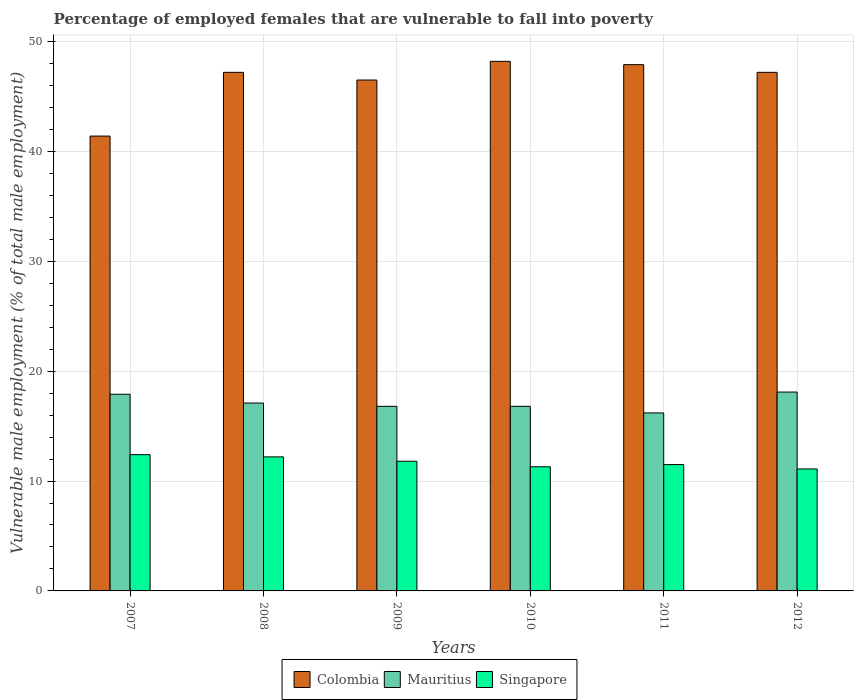Are the number of bars on each tick of the X-axis equal?
Offer a very short reply. Yes. How many bars are there on the 3rd tick from the left?
Provide a succinct answer. 3. How many bars are there on the 3rd tick from the right?
Ensure brevity in your answer.  3. What is the label of the 2nd group of bars from the left?
Your answer should be compact. 2008. In how many cases, is the number of bars for a given year not equal to the number of legend labels?
Offer a very short reply. 0. What is the percentage of employed females who are vulnerable to fall into poverty in Colombia in 2008?
Provide a short and direct response. 47.2. Across all years, what is the maximum percentage of employed females who are vulnerable to fall into poverty in Colombia?
Offer a very short reply. 48.2. Across all years, what is the minimum percentage of employed females who are vulnerable to fall into poverty in Mauritius?
Make the answer very short. 16.2. In which year was the percentage of employed females who are vulnerable to fall into poverty in Colombia minimum?
Keep it short and to the point. 2007. What is the total percentage of employed females who are vulnerable to fall into poverty in Mauritius in the graph?
Your answer should be very brief. 102.9. What is the difference between the percentage of employed females who are vulnerable to fall into poverty in Mauritius in 2007 and that in 2012?
Ensure brevity in your answer.  -0.2. What is the difference between the percentage of employed females who are vulnerable to fall into poverty in Colombia in 2007 and the percentage of employed females who are vulnerable to fall into poverty in Mauritius in 2009?
Ensure brevity in your answer.  24.6. What is the average percentage of employed females who are vulnerable to fall into poverty in Colombia per year?
Offer a very short reply. 46.4. In the year 2010, what is the difference between the percentage of employed females who are vulnerable to fall into poverty in Singapore and percentage of employed females who are vulnerable to fall into poverty in Colombia?
Provide a succinct answer. -36.9. In how many years, is the percentage of employed females who are vulnerable to fall into poverty in Mauritius greater than 16 %?
Ensure brevity in your answer.  6. What is the ratio of the percentage of employed females who are vulnerable to fall into poverty in Mauritius in 2007 to that in 2010?
Provide a succinct answer. 1.07. Is the percentage of employed females who are vulnerable to fall into poverty in Mauritius in 2007 less than that in 2011?
Ensure brevity in your answer.  No. What is the difference between the highest and the second highest percentage of employed females who are vulnerable to fall into poverty in Colombia?
Your answer should be compact. 0.3. What is the difference between the highest and the lowest percentage of employed females who are vulnerable to fall into poverty in Colombia?
Provide a succinct answer. 6.8. In how many years, is the percentage of employed females who are vulnerable to fall into poverty in Mauritius greater than the average percentage of employed females who are vulnerable to fall into poverty in Mauritius taken over all years?
Provide a short and direct response. 2. Is the sum of the percentage of employed females who are vulnerable to fall into poverty in Colombia in 2010 and 2012 greater than the maximum percentage of employed females who are vulnerable to fall into poverty in Singapore across all years?
Your answer should be very brief. Yes. What does the 1st bar from the left in 2010 represents?
Provide a succinct answer. Colombia. What does the 2nd bar from the right in 2012 represents?
Give a very brief answer. Mauritius. Is it the case that in every year, the sum of the percentage of employed females who are vulnerable to fall into poverty in Singapore and percentage of employed females who are vulnerable to fall into poverty in Mauritius is greater than the percentage of employed females who are vulnerable to fall into poverty in Colombia?
Provide a succinct answer. No. How many bars are there?
Give a very brief answer. 18. Are all the bars in the graph horizontal?
Give a very brief answer. No. How many years are there in the graph?
Your answer should be very brief. 6. What is the difference between two consecutive major ticks on the Y-axis?
Keep it short and to the point. 10. Does the graph contain any zero values?
Give a very brief answer. No. Does the graph contain grids?
Offer a very short reply. Yes. Where does the legend appear in the graph?
Offer a very short reply. Bottom center. What is the title of the graph?
Offer a terse response. Percentage of employed females that are vulnerable to fall into poverty. Does "St. Kitts and Nevis" appear as one of the legend labels in the graph?
Make the answer very short. No. What is the label or title of the Y-axis?
Offer a very short reply. Vulnerable male employment (% of total male employment). What is the Vulnerable male employment (% of total male employment) in Colombia in 2007?
Offer a very short reply. 41.4. What is the Vulnerable male employment (% of total male employment) of Mauritius in 2007?
Offer a very short reply. 17.9. What is the Vulnerable male employment (% of total male employment) in Singapore in 2007?
Ensure brevity in your answer.  12.4. What is the Vulnerable male employment (% of total male employment) of Colombia in 2008?
Make the answer very short. 47.2. What is the Vulnerable male employment (% of total male employment) in Mauritius in 2008?
Provide a succinct answer. 17.1. What is the Vulnerable male employment (% of total male employment) in Singapore in 2008?
Give a very brief answer. 12.2. What is the Vulnerable male employment (% of total male employment) in Colombia in 2009?
Provide a succinct answer. 46.5. What is the Vulnerable male employment (% of total male employment) in Mauritius in 2009?
Your answer should be very brief. 16.8. What is the Vulnerable male employment (% of total male employment) in Singapore in 2009?
Give a very brief answer. 11.8. What is the Vulnerable male employment (% of total male employment) of Colombia in 2010?
Provide a succinct answer. 48.2. What is the Vulnerable male employment (% of total male employment) of Mauritius in 2010?
Your response must be concise. 16.8. What is the Vulnerable male employment (% of total male employment) of Singapore in 2010?
Your answer should be very brief. 11.3. What is the Vulnerable male employment (% of total male employment) of Colombia in 2011?
Give a very brief answer. 47.9. What is the Vulnerable male employment (% of total male employment) in Mauritius in 2011?
Keep it short and to the point. 16.2. What is the Vulnerable male employment (% of total male employment) in Colombia in 2012?
Keep it short and to the point. 47.2. What is the Vulnerable male employment (% of total male employment) of Mauritius in 2012?
Your response must be concise. 18.1. What is the Vulnerable male employment (% of total male employment) of Singapore in 2012?
Provide a short and direct response. 11.1. Across all years, what is the maximum Vulnerable male employment (% of total male employment) in Colombia?
Provide a short and direct response. 48.2. Across all years, what is the maximum Vulnerable male employment (% of total male employment) in Mauritius?
Your answer should be very brief. 18.1. Across all years, what is the maximum Vulnerable male employment (% of total male employment) of Singapore?
Provide a succinct answer. 12.4. Across all years, what is the minimum Vulnerable male employment (% of total male employment) of Colombia?
Make the answer very short. 41.4. Across all years, what is the minimum Vulnerable male employment (% of total male employment) of Mauritius?
Make the answer very short. 16.2. Across all years, what is the minimum Vulnerable male employment (% of total male employment) in Singapore?
Your answer should be very brief. 11.1. What is the total Vulnerable male employment (% of total male employment) of Colombia in the graph?
Make the answer very short. 278.4. What is the total Vulnerable male employment (% of total male employment) of Mauritius in the graph?
Make the answer very short. 102.9. What is the total Vulnerable male employment (% of total male employment) of Singapore in the graph?
Your answer should be very brief. 70.3. What is the difference between the Vulnerable male employment (% of total male employment) of Mauritius in 2007 and that in 2008?
Your answer should be compact. 0.8. What is the difference between the Vulnerable male employment (% of total male employment) of Colombia in 2007 and that in 2009?
Your response must be concise. -5.1. What is the difference between the Vulnerable male employment (% of total male employment) of Mauritius in 2007 and that in 2009?
Give a very brief answer. 1.1. What is the difference between the Vulnerable male employment (% of total male employment) in Singapore in 2007 and that in 2009?
Your response must be concise. 0.6. What is the difference between the Vulnerable male employment (% of total male employment) of Mauritius in 2007 and that in 2010?
Make the answer very short. 1.1. What is the difference between the Vulnerable male employment (% of total male employment) of Singapore in 2007 and that in 2010?
Provide a succinct answer. 1.1. What is the difference between the Vulnerable male employment (% of total male employment) in Colombia in 2007 and that in 2011?
Offer a terse response. -6.5. What is the difference between the Vulnerable male employment (% of total male employment) in Singapore in 2007 and that in 2011?
Provide a succinct answer. 0.9. What is the difference between the Vulnerable male employment (% of total male employment) of Mauritius in 2007 and that in 2012?
Give a very brief answer. -0.2. What is the difference between the Vulnerable male employment (% of total male employment) of Singapore in 2007 and that in 2012?
Your response must be concise. 1.3. What is the difference between the Vulnerable male employment (% of total male employment) in Mauritius in 2008 and that in 2009?
Your answer should be compact. 0.3. What is the difference between the Vulnerable male employment (% of total male employment) in Mauritius in 2008 and that in 2010?
Offer a very short reply. 0.3. What is the difference between the Vulnerable male employment (% of total male employment) in Colombia in 2008 and that in 2011?
Keep it short and to the point. -0.7. What is the difference between the Vulnerable male employment (% of total male employment) of Mauritius in 2008 and that in 2012?
Offer a terse response. -1. What is the difference between the Vulnerable male employment (% of total male employment) of Singapore in 2008 and that in 2012?
Your answer should be very brief. 1.1. What is the difference between the Vulnerable male employment (% of total male employment) in Colombia in 2009 and that in 2010?
Keep it short and to the point. -1.7. What is the difference between the Vulnerable male employment (% of total male employment) of Colombia in 2009 and that in 2011?
Your response must be concise. -1.4. What is the difference between the Vulnerable male employment (% of total male employment) in Colombia in 2010 and that in 2012?
Keep it short and to the point. 1. What is the difference between the Vulnerable male employment (% of total male employment) of Mauritius in 2010 and that in 2012?
Your response must be concise. -1.3. What is the difference between the Vulnerable male employment (% of total male employment) in Singapore in 2010 and that in 2012?
Offer a terse response. 0.2. What is the difference between the Vulnerable male employment (% of total male employment) of Colombia in 2011 and that in 2012?
Offer a terse response. 0.7. What is the difference between the Vulnerable male employment (% of total male employment) of Mauritius in 2011 and that in 2012?
Offer a terse response. -1.9. What is the difference between the Vulnerable male employment (% of total male employment) in Colombia in 2007 and the Vulnerable male employment (% of total male employment) in Mauritius in 2008?
Ensure brevity in your answer.  24.3. What is the difference between the Vulnerable male employment (% of total male employment) of Colombia in 2007 and the Vulnerable male employment (% of total male employment) of Singapore in 2008?
Make the answer very short. 29.2. What is the difference between the Vulnerable male employment (% of total male employment) in Colombia in 2007 and the Vulnerable male employment (% of total male employment) in Mauritius in 2009?
Keep it short and to the point. 24.6. What is the difference between the Vulnerable male employment (% of total male employment) of Colombia in 2007 and the Vulnerable male employment (% of total male employment) of Singapore in 2009?
Provide a short and direct response. 29.6. What is the difference between the Vulnerable male employment (% of total male employment) of Colombia in 2007 and the Vulnerable male employment (% of total male employment) of Mauritius in 2010?
Provide a succinct answer. 24.6. What is the difference between the Vulnerable male employment (% of total male employment) of Colombia in 2007 and the Vulnerable male employment (% of total male employment) of Singapore in 2010?
Offer a very short reply. 30.1. What is the difference between the Vulnerable male employment (% of total male employment) in Colombia in 2007 and the Vulnerable male employment (% of total male employment) in Mauritius in 2011?
Provide a succinct answer. 25.2. What is the difference between the Vulnerable male employment (% of total male employment) in Colombia in 2007 and the Vulnerable male employment (% of total male employment) in Singapore in 2011?
Give a very brief answer. 29.9. What is the difference between the Vulnerable male employment (% of total male employment) of Mauritius in 2007 and the Vulnerable male employment (% of total male employment) of Singapore in 2011?
Ensure brevity in your answer.  6.4. What is the difference between the Vulnerable male employment (% of total male employment) in Colombia in 2007 and the Vulnerable male employment (% of total male employment) in Mauritius in 2012?
Keep it short and to the point. 23.3. What is the difference between the Vulnerable male employment (% of total male employment) of Colombia in 2007 and the Vulnerable male employment (% of total male employment) of Singapore in 2012?
Your answer should be very brief. 30.3. What is the difference between the Vulnerable male employment (% of total male employment) in Colombia in 2008 and the Vulnerable male employment (% of total male employment) in Mauritius in 2009?
Provide a short and direct response. 30.4. What is the difference between the Vulnerable male employment (% of total male employment) in Colombia in 2008 and the Vulnerable male employment (% of total male employment) in Singapore in 2009?
Your response must be concise. 35.4. What is the difference between the Vulnerable male employment (% of total male employment) in Colombia in 2008 and the Vulnerable male employment (% of total male employment) in Mauritius in 2010?
Offer a very short reply. 30.4. What is the difference between the Vulnerable male employment (% of total male employment) of Colombia in 2008 and the Vulnerable male employment (% of total male employment) of Singapore in 2010?
Offer a terse response. 35.9. What is the difference between the Vulnerable male employment (% of total male employment) in Colombia in 2008 and the Vulnerable male employment (% of total male employment) in Mauritius in 2011?
Keep it short and to the point. 31. What is the difference between the Vulnerable male employment (% of total male employment) of Colombia in 2008 and the Vulnerable male employment (% of total male employment) of Singapore in 2011?
Provide a short and direct response. 35.7. What is the difference between the Vulnerable male employment (% of total male employment) in Colombia in 2008 and the Vulnerable male employment (% of total male employment) in Mauritius in 2012?
Offer a very short reply. 29.1. What is the difference between the Vulnerable male employment (% of total male employment) in Colombia in 2008 and the Vulnerable male employment (% of total male employment) in Singapore in 2012?
Your answer should be compact. 36.1. What is the difference between the Vulnerable male employment (% of total male employment) in Mauritius in 2008 and the Vulnerable male employment (% of total male employment) in Singapore in 2012?
Your answer should be compact. 6. What is the difference between the Vulnerable male employment (% of total male employment) of Colombia in 2009 and the Vulnerable male employment (% of total male employment) of Mauritius in 2010?
Your response must be concise. 29.7. What is the difference between the Vulnerable male employment (% of total male employment) in Colombia in 2009 and the Vulnerable male employment (% of total male employment) in Singapore in 2010?
Ensure brevity in your answer.  35.2. What is the difference between the Vulnerable male employment (% of total male employment) of Mauritius in 2009 and the Vulnerable male employment (% of total male employment) of Singapore in 2010?
Provide a succinct answer. 5.5. What is the difference between the Vulnerable male employment (% of total male employment) of Colombia in 2009 and the Vulnerable male employment (% of total male employment) of Mauritius in 2011?
Your answer should be very brief. 30.3. What is the difference between the Vulnerable male employment (% of total male employment) of Colombia in 2009 and the Vulnerable male employment (% of total male employment) of Mauritius in 2012?
Provide a short and direct response. 28.4. What is the difference between the Vulnerable male employment (% of total male employment) of Colombia in 2009 and the Vulnerable male employment (% of total male employment) of Singapore in 2012?
Offer a terse response. 35.4. What is the difference between the Vulnerable male employment (% of total male employment) of Mauritius in 2009 and the Vulnerable male employment (% of total male employment) of Singapore in 2012?
Provide a short and direct response. 5.7. What is the difference between the Vulnerable male employment (% of total male employment) in Colombia in 2010 and the Vulnerable male employment (% of total male employment) in Singapore in 2011?
Provide a short and direct response. 36.7. What is the difference between the Vulnerable male employment (% of total male employment) of Colombia in 2010 and the Vulnerable male employment (% of total male employment) of Mauritius in 2012?
Keep it short and to the point. 30.1. What is the difference between the Vulnerable male employment (% of total male employment) of Colombia in 2010 and the Vulnerable male employment (% of total male employment) of Singapore in 2012?
Your response must be concise. 37.1. What is the difference between the Vulnerable male employment (% of total male employment) in Colombia in 2011 and the Vulnerable male employment (% of total male employment) in Mauritius in 2012?
Provide a succinct answer. 29.8. What is the difference between the Vulnerable male employment (% of total male employment) of Colombia in 2011 and the Vulnerable male employment (% of total male employment) of Singapore in 2012?
Offer a very short reply. 36.8. What is the average Vulnerable male employment (% of total male employment) of Colombia per year?
Provide a short and direct response. 46.4. What is the average Vulnerable male employment (% of total male employment) in Mauritius per year?
Provide a succinct answer. 17.15. What is the average Vulnerable male employment (% of total male employment) of Singapore per year?
Your answer should be compact. 11.72. In the year 2007, what is the difference between the Vulnerable male employment (% of total male employment) of Mauritius and Vulnerable male employment (% of total male employment) of Singapore?
Make the answer very short. 5.5. In the year 2008, what is the difference between the Vulnerable male employment (% of total male employment) in Colombia and Vulnerable male employment (% of total male employment) in Mauritius?
Provide a succinct answer. 30.1. In the year 2008, what is the difference between the Vulnerable male employment (% of total male employment) in Mauritius and Vulnerable male employment (% of total male employment) in Singapore?
Offer a terse response. 4.9. In the year 2009, what is the difference between the Vulnerable male employment (% of total male employment) in Colombia and Vulnerable male employment (% of total male employment) in Mauritius?
Offer a very short reply. 29.7. In the year 2009, what is the difference between the Vulnerable male employment (% of total male employment) of Colombia and Vulnerable male employment (% of total male employment) of Singapore?
Your answer should be very brief. 34.7. In the year 2010, what is the difference between the Vulnerable male employment (% of total male employment) of Colombia and Vulnerable male employment (% of total male employment) of Mauritius?
Offer a very short reply. 31.4. In the year 2010, what is the difference between the Vulnerable male employment (% of total male employment) of Colombia and Vulnerable male employment (% of total male employment) of Singapore?
Your response must be concise. 36.9. In the year 2010, what is the difference between the Vulnerable male employment (% of total male employment) of Mauritius and Vulnerable male employment (% of total male employment) of Singapore?
Your answer should be compact. 5.5. In the year 2011, what is the difference between the Vulnerable male employment (% of total male employment) in Colombia and Vulnerable male employment (% of total male employment) in Mauritius?
Ensure brevity in your answer.  31.7. In the year 2011, what is the difference between the Vulnerable male employment (% of total male employment) in Colombia and Vulnerable male employment (% of total male employment) in Singapore?
Provide a short and direct response. 36.4. In the year 2012, what is the difference between the Vulnerable male employment (% of total male employment) in Colombia and Vulnerable male employment (% of total male employment) in Mauritius?
Offer a terse response. 29.1. In the year 2012, what is the difference between the Vulnerable male employment (% of total male employment) of Colombia and Vulnerable male employment (% of total male employment) of Singapore?
Your response must be concise. 36.1. What is the ratio of the Vulnerable male employment (% of total male employment) of Colombia in 2007 to that in 2008?
Provide a short and direct response. 0.88. What is the ratio of the Vulnerable male employment (% of total male employment) in Mauritius in 2007 to that in 2008?
Your answer should be compact. 1.05. What is the ratio of the Vulnerable male employment (% of total male employment) in Singapore in 2007 to that in 2008?
Provide a succinct answer. 1.02. What is the ratio of the Vulnerable male employment (% of total male employment) of Colombia in 2007 to that in 2009?
Your response must be concise. 0.89. What is the ratio of the Vulnerable male employment (% of total male employment) in Mauritius in 2007 to that in 2009?
Provide a succinct answer. 1.07. What is the ratio of the Vulnerable male employment (% of total male employment) in Singapore in 2007 to that in 2009?
Offer a terse response. 1.05. What is the ratio of the Vulnerable male employment (% of total male employment) in Colombia in 2007 to that in 2010?
Keep it short and to the point. 0.86. What is the ratio of the Vulnerable male employment (% of total male employment) in Mauritius in 2007 to that in 2010?
Ensure brevity in your answer.  1.07. What is the ratio of the Vulnerable male employment (% of total male employment) of Singapore in 2007 to that in 2010?
Provide a short and direct response. 1.1. What is the ratio of the Vulnerable male employment (% of total male employment) in Colombia in 2007 to that in 2011?
Offer a very short reply. 0.86. What is the ratio of the Vulnerable male employment (% of total male employment) of Mauritius in 2007 to that in 2011?
Your answer should be compact. 1.1. What is the ratio of the Vulnerable male employment (% of total male employment) in Singapore in 2007 to that in 2011?
Make the answer very short. 1.08. What is the ratio of the Vulnerable male employment (% of total male employment) of Colombia in 2007 to that in 2012?
Keep it short and to the point. 0.88. What is the ratio of the Vulnerable male employment (% of total male employment) in Mauritius in 2007 to that in 2012?
Your answer should be very brief. 0.99. What is the ratio of the Vulnerable male employment (% of total male employment) of Singapore in 2007 to that in 2012?
Your answer should be compact. 1.12. What is the ratio of the Vulnerable male employment (% of total male employment) in Colombia in 2008 to that in 2009?
Your answer should be very brief. 1.02. What is the ratio of the Vulnerable male employment (% of total male employment) of Mauritius in 2008 to that in 2009?
Offer a very short reply. 1.02. What is the ratio of the Vulnerable male employment (% of total male employment) of Singapore in 2008 to that in 2009?
Provide a short and direct response. 1.03. What is the ratio of the Vulnerable male employment (% of total male employment) of Colombia in 2008 to that in 2010?
Make the answer very short. 0.98. What is the ratio of the Vulnerable male employment (% of total male employment) in Mauritius in 2008 to that in 2010?
Offer a terse response. 1.02. What is the ratio of the Vulnerable male employment (% of total male employment) of Singapore in 2008 to that in 2010?
Provide a short and direct response. 1.08. What is the ratio of the Vulnerable male employment (% of total male employment) of Colombia in 2008 to that in 2011?
Ensure brevity in your answer.  0.99. What is the ratio of the Vulnerable male employment (% of total male employment) of Mauritius in 2008 to that in 2011?
Your answer should be very brief. 1.06. What is the ratio of the Vulnerable male employment (% of total male employment) in Singapore in 2008 to that in 2011?
Give a very brief answer. 1.06. What is the ratio of the Vulnerable male employment (% of total male employment) of Mauritius in 2008 to that in 2012?
Give a very brief answer. 0.94. What is the ratio of the Vulnerable male employment (% of total male employment) in Singapore in 2008 to that in 2012?
Give a very brief answer. 1.1. What is the ratio of the Vulnerable male employment (% of total male employment) of Colombia in 2009 to that in 2010?
Offer a very short reply. 0.96. What is the ratio of the Vulnerable male employment (% of total male employment) of Singapore in 2009 to that in 2010?
Offer a very short reply. 1.04. What is the ratio of the Vulnerable male employment (% of total male employment) in Colombia in 2009 to that in 2011?
Make the answer very short. 0.97. What is the ratio of the Vulnerable male employment (% of total male employment) in Mauritius in 2009 to that in 2011?
Ensure brevity in your answer.  1.04. What is the ratio of the Vulnerable male employment (% of total male employment) of Singapore in 2009 to that in 2011?
Provide a succinct answer. 1.03. What is the ratio of the Vulnerable male employment (% of total male employment) of Colombia in 2009 to that in 2012?
Your answer should be very brief. 0.99. What is the ratio of the Vulnerable male employment (% of total male employment) in Mauritius in 2009 to that in 2012?
Offer a very short reply. 0.93. What is the ratio of the Vulnerable male employment (% of total male employment) of Singapore in 2009 to that in 2012?
Your response must be concise. 1.06. What is the ratio of the Vulnerable male employment (% of total male employment) of Colombia in 2010 to that in 2011?
Offer a terse response. 1.01. What is the ratio of the Vulnerable male employment (% of total male employment) in Singapore in 2010 to that in 2011?
Give a very brief answer. 0.98. What is the ratio of the Vulnerable male employment (% of total male employment) of Colombia in 2010 to that in 2012?
Provide a succinct answer. 1.02. What is the ratio of the Vulnerable male employment (% of total male employment) in Mauritius in 2010 to that in 2012?
Give a very brief answer. 0.93. What is the ratio of the Vulnerable male employment (% of total male employment) of Singapore in 2010 to that in 2012?
Keep it short and to the point. 1.02. What is the ratio of the Vulnerable male employment (% of total male employment) of Colombia in 2011 to that in 2012?
Make the answer very short. 1.01. What is the ratio of the Vulnerable male employment (% of total male employment) in Mauritius in 2011 to that in 2012?
Your answer should be very brief. 0.9. What is the ratio of the Vulnerable male employment (% of total male employment) in Singapore in 2011 to that in 2012?
Ensure brevity in your answer.  1.04. What is the difference between the highest and the second highest Vulnerable male employment (% of total male employment) of Colombia?
Make the answer very short. 0.3. What is the difference between the highest and the second highest Vulnerable male employment (% of total male employment) in Mauritius?
Your response must be concise. 0.2. 